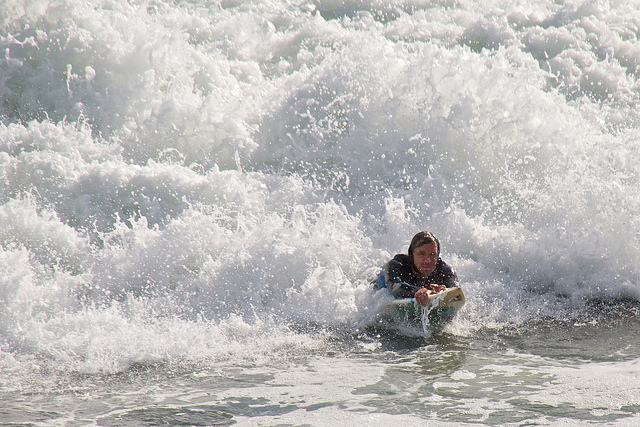Describe the equipment the person is using. The individual is using a surfboard, which is a specially designed board for riding waves. Can you tell me more about the surfboard? Certainly! A surfboard is typically made of lightweight yet sturdy materials like foam and fiberglass. It's designed to be buoyant enough to keep the surfer afloat while also being shaped to cut through and ride on the waves efficiently. 